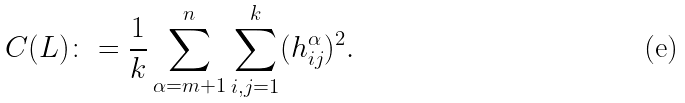Convert formula to latex. <formula><loc_0><loc_0><loc_500><loc_500>C ( L ) \colon = \frac { 1 } { k } \sum _ { \alpha = m + 1 } ^ { n } \sum _ { i , j = 1 } ^ { k } ( h _ { i j } ^ { \alpha } ) ^ { 2 } .</formula> 